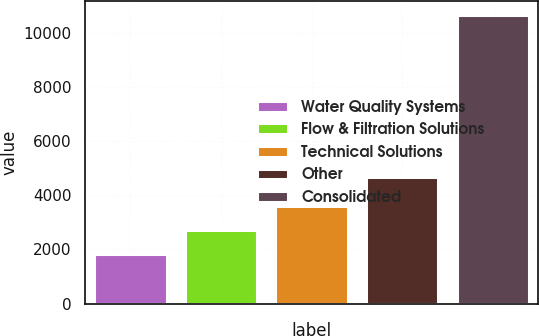Convert chart. <chart><loc_0><loc_0><loc_500><loc_500><bar_chart><fcel>Water Quality Systems<fcel>Flow & Filtration Solutions<fcel>Technical Solutions<fcel>Other<fcel>Consolidated<nl><fcel>1828.3<fcel>2709.85<fcel>3591.4<fcel>4658.2<fcel>10643.8<nl></chart> 